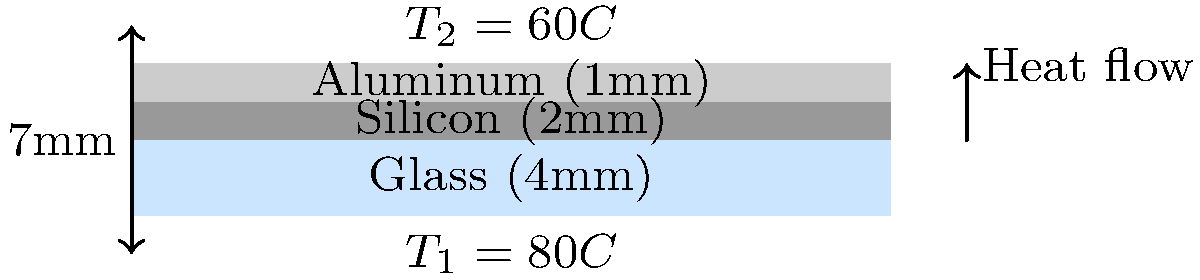A solar panel consists of three layers: 4mm glass, 2mm silicon, and 1mm aluminum. The temperature at the top surface (glass) is 80°C, and at the bottom surface (aluminum) is 60°C. If the thermal conductivities of glass, silicon, and aluminum are 1.0 W/mK, 150 W/mK, and 205 W/mK respectively, what is the heat flux through the solar panel in W/m²? To solve this problem, we'll use Fourier's law of heat conduction and the concept of thermal resistance in series. Let's follow these steps:

1) Fourier's law states that heat flux $q = -k \frac{dT}{dx}$, where $k$ is thermal conductivity.

2) For multiple layers, we can use the concept of thermal resistance in series:
   $R_{total} = R_1 + R_2 + R_3$

3) Thermal resistance for each layer is given by $R = \frac{L}{k}$, where $L$ is thickness.

4) Calculate the thermal resistances:
   $R_{glass} = \frac{0.004}{1.0} = 0.004 \, m^2K/W$
   $R_{silicon} = \frac{0.002}{150} = 1.33 \times 10^{-5} \, m^2K/W$
   $R_{aluminum} = \frac{0.001}{205} = 4.88 \times 10^{-6} \, m^2K/W$

5) Total thermal resistance:
   $R_{total} = 0.004 + 1.33 \times 10^{-5} + 4.88 \times 10^{-6} = 0.004018 \, m^2K/W$

6) Temperature difference: $\Delta T = 80°C - 60°C = 20°C$

7) Heat flux: $q = \frac{\Delta T}{R_{total}} = \frac{20}{0.004018} = 4977.6 \, W/m^2$

Therefore, the heat flux through the solar panel is approximately 4978 W/m².
Answer: 4978 W/m² 